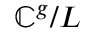<formula> <loc_0><loc_0><loc_500><loc_500>\mathbb { C } ^ { g } / L</formula> 